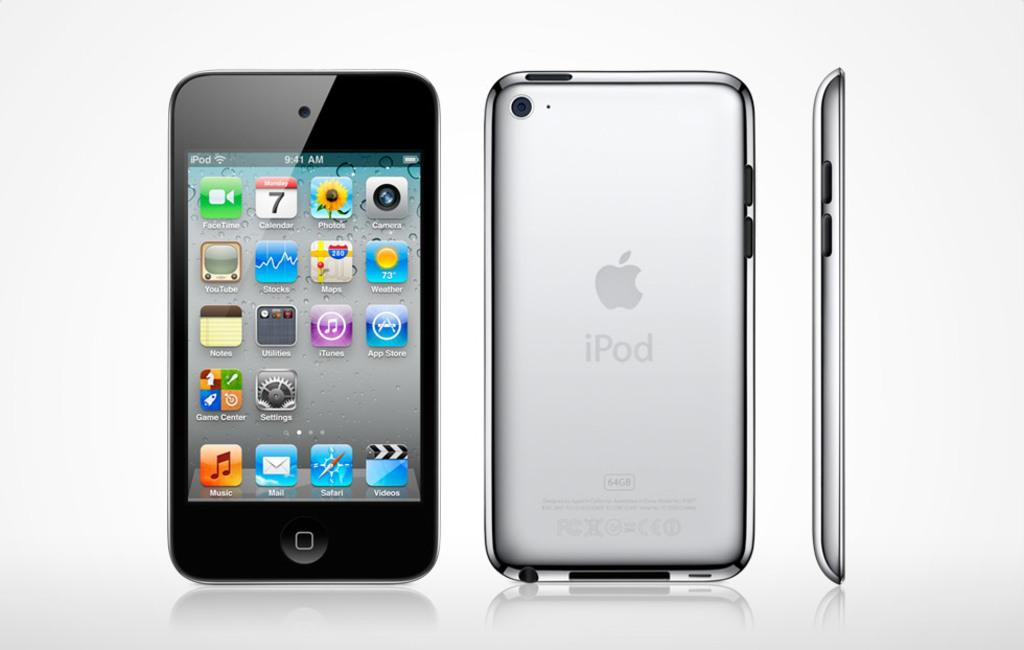<image>
Relay a brief, clear account of the picture shown. An iPod with FaceTime on its homescreen shown from three different angles. 